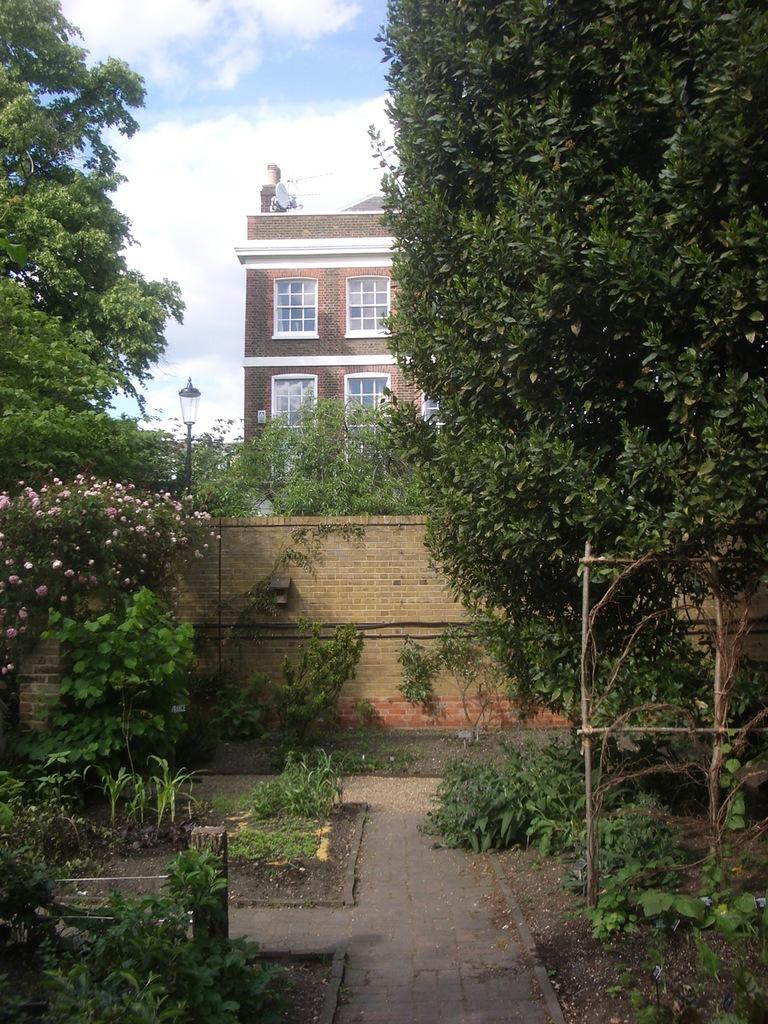What type of structure can be seen in the background of the image? There is a building in the background of the image. What can be seen in the sky in the image? The sky is visible in the background of the image. What type of vegetation is present in the image? There are trees, plants, and flowers in the image. What type of man-made object is present in the image? There is a light pole and a satellite dish in the image. What type of surface is visible in the image? There is a wall in the image. How does the vacation affect the digestion of the flowers in the image? There is no mention of a vacation or any living organisms in the image, so it is not possible to determine how a vacation might affect the digestion of the flowers. 